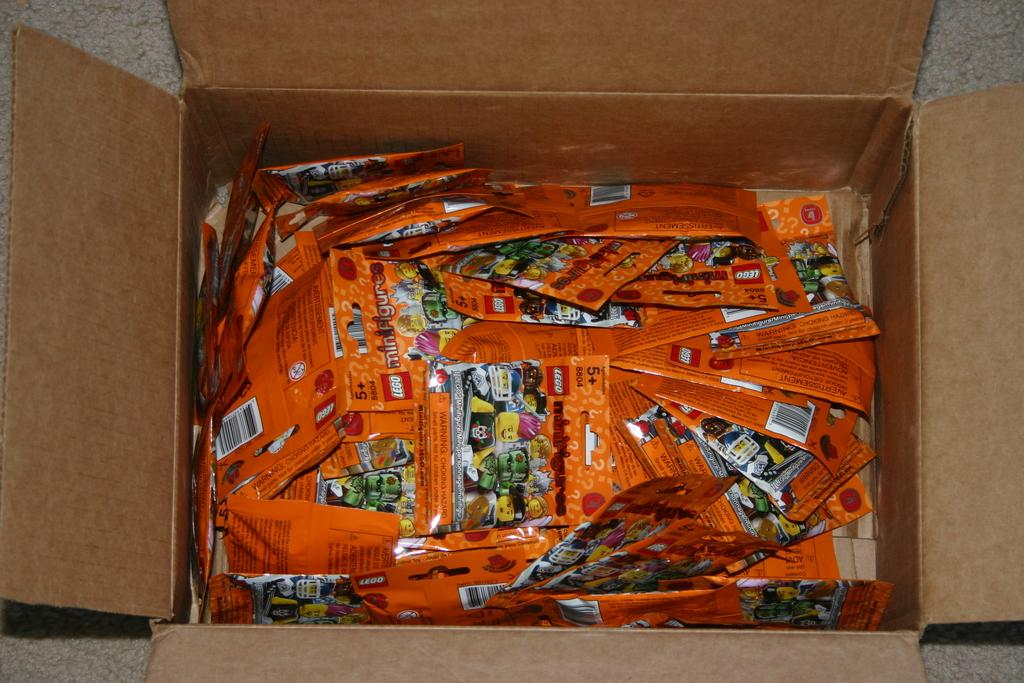What is inside the carton box in the image? There are many packets in the carton box. Can you describe the surface visible in the image? Unfortunately, the provided facts do not give any information about the surface visible in the image. What historical event is depicted on the packets in the image? There is no information provided about the contents or design of the packets, so it is not possible to determine if any historical events are depicted on them. 